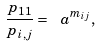<formula> <loc_0><loc_0><loc_500><loc_500>\frac { p _ { 1 1 } } { p _ { i , j } } = \ a ^ { m _ { i j } } ,</formula> 